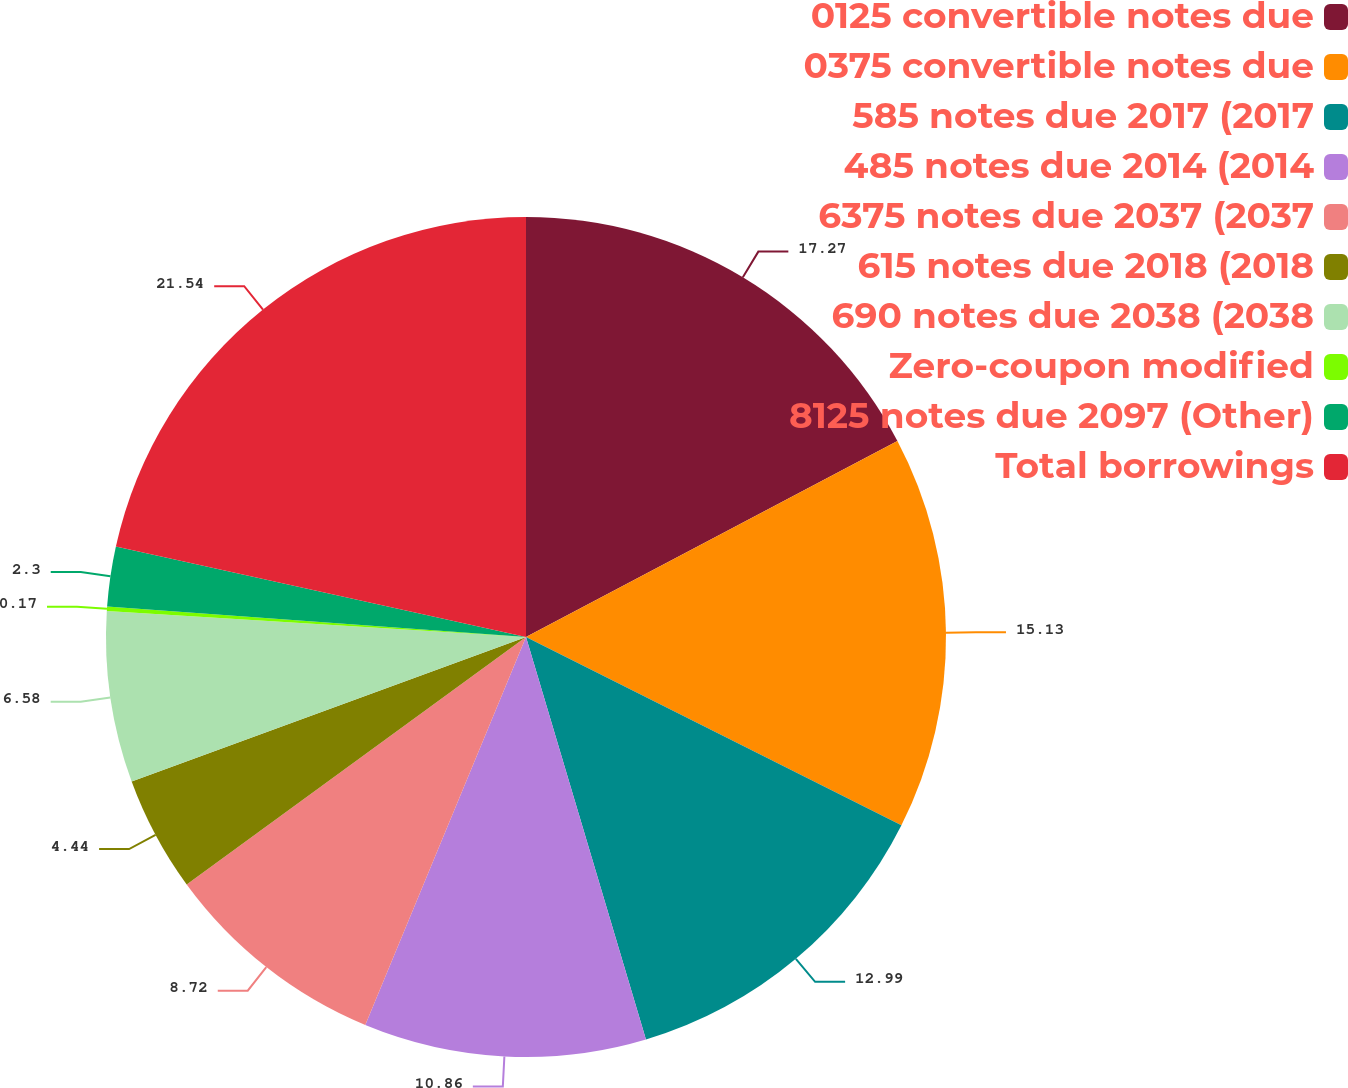<chart> <loc_0><loc_0><loc_500><loc_500><pie_chart><fcel>0125 convertible notes due<fcel>0375 convertible notes due<fcel>585 notes due 2017 (2017<fcel>485 notes due 2014 (2014<fcel>6375 notes due 2037 (2037<fcel>615 notes due 2018 (2018<fcel>690 notes due 2038 (2038<fcel>Zero-coupon modified<fcel>8125 notes due 2097 (Other)<fcel>Total borrowings<nl><fcel>17.27%<fcel>15.13%<fcel>12.99%<fcel>10.86%<fcel>8.72%<fcel>4.44%<fcel>6.58%<fcel>0.17%<fcel>2.3%<fcel>21.54%<nl></chart> 